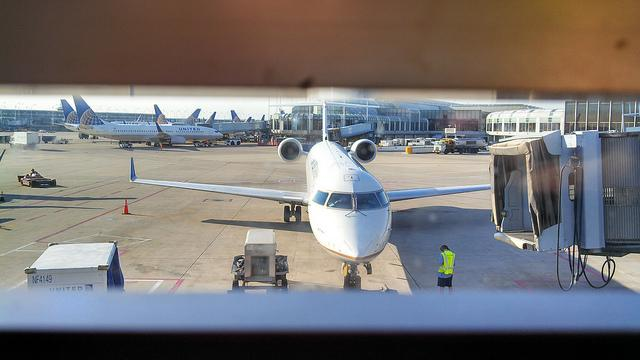What is the large vehicle here? Please explain your reasoning. airplane. The large vehicle has fixed wings. it is not armored and cannot travel underwater. 